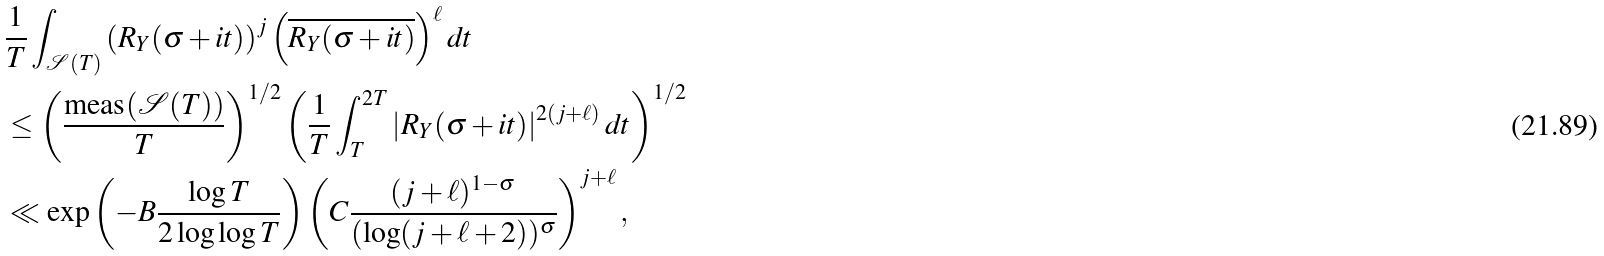<formula> <loc_0><loc_0><loc_500><loc_500>& \frac { 1 } { T } \int _ { \mathcal { S } ( T ) } \left ( R _ { Y } ( \sigma + i t ) \right ) ^ { j } \left ( \overline { R _ { Y } ( \sigma + i t ) } \right ) ^ { \ell } d t \\ & \leq \left ( \frac { \text {meas} ( \mathcal { S } ( T ) ) } { T } \right ) ^ { 1 / 2 } \left ( \frac { 1 } { T } \int _ { T } ^ { 2 T } \left | R _ { Y } ( \sigma + i t ) \right | ^ { 2 ( j + \ell ) } d t \right ) ^ { 1 / 2 } \\ & \ll \exp \left ( - B \frac { \log T } { 2 \log \log T } \right ) \left ( C \frac { ( j + \ell ) ^ { 1 - \sigma } } { ( \log ( j + \ell + 2 ) ) ^ { \sigma } } \right ) ^ { j + \ell } , \\</formula> 